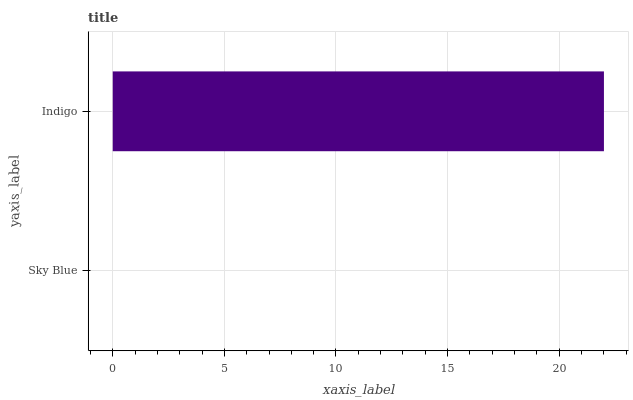Is Sky Blue the minimum?
Answer yes or no. Yes. Is Indigo the maximum?
Answer yes or no. Yes. Is Indigo the minimum?
Answer yes or no. No. Is Indigo greater than Sky Blue?
Answer yes or no. Yes. Is Sky Blue less than Indigo?
Answer yes or no. Yes. Is Sky Blue greater than Indigo?
Answer yes or no. No. Is Indigo less than Sky Blue?
Answer yes or no. No. Is Indigo the high median?
Answer yes or no. Yes. Is Sky Blue the low median?
Answer yes or no. Yes. Is Sky Blue the high median?
Answer yes or no. No. Is Indigo the low median?
Answer yes or no. No. 